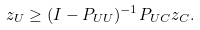<formula> <loc_0><loc_0><loc_500><loc_500>z _ { U } \geq ( I - P _ { U U } ) ^ { - 1 } P _ { U C } z _ { C } .</formula> 